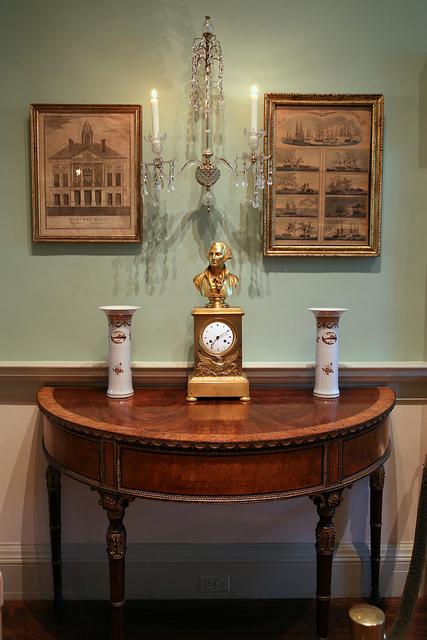What is the lighting piece called on the wall?
Quick response, please. Candelabra. Whose bust is on top of the clock?
Answer briefly. George washington. Where are the sketches?
Quick response, please. Wall. What is in the center of the table?
Keep it brief. Clock. 